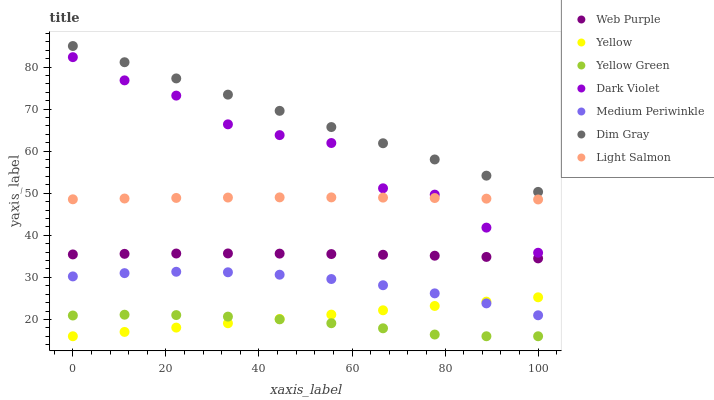Does Yellow Green have the minimum area under the curve?
Answer yes or no. Yes. Does Dim Gray have the maximum area under the curve?
Answer yes or no. Yes. Does Dim Gray have the minimum area under the curve?
Answer yes or no. No. Does Yellow Green have the maximum area under the curve?
Answer yes or no. No. Is Yellow the smoothest?
Answer yes or no. Yes. Is Dark Violet the roughest?
Answer yes or no. Yes. Is Dim Gray the smoothest?
Answer yes or no. No. Is Dim Gray the roughest?
Answer yes or no. No. Does Yellow Green have the lowest value?
Answer yes or no. Yes. Does Dim Gray have the lowest value?
Answer yes or no. No. Does Dim Gray have the highest value?
Answer yes or no. Yes. Does Yellow Green have the highest value?
Answer yes or no. No. Is Yellow less than Dim Gray?
Answer yes or no. Yes. Is Dim Gray greater than Web Purple?
Answer yes or no. Yes. Does Dark Violet intersect Light Salmon?
Answer yes or no. Yes. Is Dark Violet less than Light Salmon?
Answer yes or no. No. Is Dark Violet greater than Light Salmon?
Answer yes or no. No. Does Yellow intersect Dim Gray?
Answer yes or no. No. 